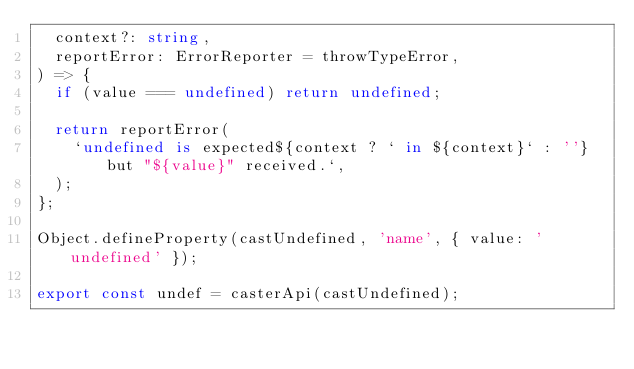Convert code to text. <code><loc_0><loc_0><loc_500><loc_500><_TypeScript_>  context?: string,
  reportError: ErrorReporter = throwTypeError,
) => {
  if (value === undefined) return undefined;

  return reportError(
    `undefined is expected${context ? ` in ${context}` : ''} but "${value}" received.`,
  );
};

Object.defineProperty(castUndefined, 'name', { value: 'undefined' });

export const undef = casterApi(castUndefined);
</code> 